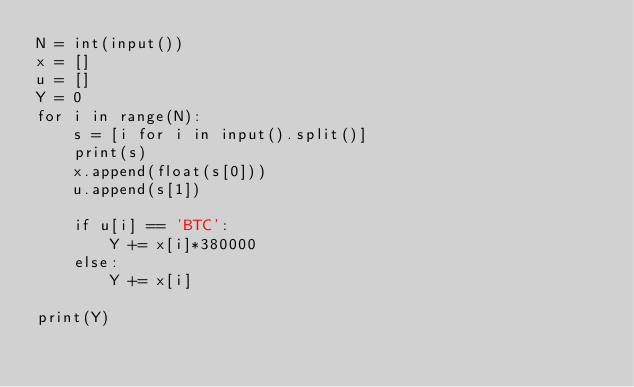<code> <loc_0><loc_0><loc_500><loc_500><_Python_>N = int(input())
x = []
u = []
Y = 0
for i in range(N):
    s = [i for i in input().split()]
    print(s)
    x.append(float(s[0]))
    u.append(s[1])

    if u[i] == 'BTC':
        Y += x[i]*380000
    else:
        Y += x[i]

print(Y)</code> 